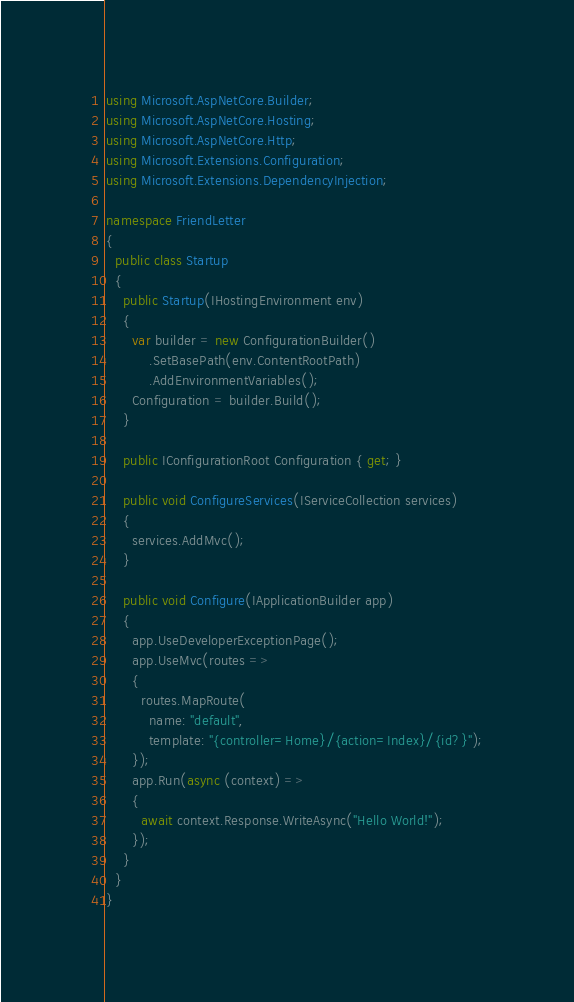<code> <loc_0><loc_0><loc_500><loc_500><_C#_>using Microsoft.AspNetCore.Builder;
using Microsoft.AspNetCore.Hosting;
using Microsoft.AspNetCore.Http;
using Microsoft.Extensions.Configuration;
using Microsoft.Extensions.DependencyInjection;

namespace FriendLetter
{
  public class Startup
  {
    public Startup(IHostingEnvironment env)
    {
      var builder = new ConfigurationBuilder()
          .SetBasePath(env.ContentRootPath)
          .AddEnvironmentVariables();
      Configuration = builder.Build();
    }

    public IConfigurationRoot Configuration { get; }

    public void ConfigureServices(IServiceCollection services)
    {
      services.AddMvc();
    }

    public void Configure(IApplicationBuilder app)
    {
      app.UseDeveloperExceptionPage();
      app.UseMvc(routes =>
      {
        routes.MapRoute(
          name: "default",
          template: "{controller=Home}/{action=Index}/{id?}");
      });
      app.Run(async (context) =>
      {
        await context.Response.WriteAsync("Hello World!");
      });
    }
  }
}</code> 